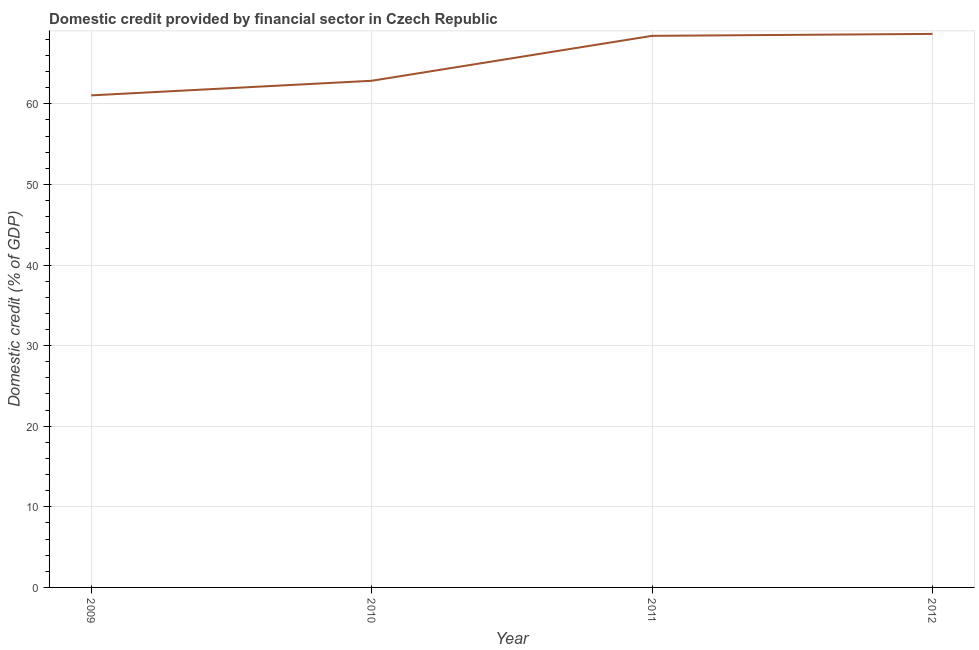What is the domestic credit provided by financial sector in 2010?
Provide a succinct answer. 62.86. Across all years, what is the maximum domestic credit provided by financial sector?
Give a very brief answer. 68.68. Across all years, what is the minimum domestic credit provided by financial sector?
Ensure brevity in your answer.  61.05. In which year was the domestic credit provided by financial sector maximum?
Your response must be concise. 2012. What is the sum of the domestic credit provided by financial sector?
Provide a short and direct response. 261.02. What is the difference between the domestic credit provided by financial sector in 2009 and 2011?
Give a very brief answer. -7.39. What is the average domestic credit provided by financial sector per year?
Ensure brevity in your answer.  65.26. What is the median domestic credit provided by financial sector?
Provide a succinct answer. 65.65. Do a majority of the years between 2011 and 2012 (inclusive) have domestic credit provided by financial sector greater than 50 %?
Provide a short and direct response. Yes. What is the ratio of the domestic credit provided by financial sector in 2009 to that in 2011?
Your response must be concise. 0.89. Is the difference between the domestic credit provided by financial sector in 2009 and 2011 greater than the difference between any two years?
Give a very brief answer. No. What is the difference between the highest and the second highest domestic credit provided by financial sector?
Your answer should be compact. 0.24. Is the sum of the domestic credit provided by financial sector in 2009 and 2010 greater than the maximum domestic credit provided by financial sector across all years?
Offer a terse response. Yes. What is the difference between the highest and the lowest domestic credit provided by financial sector?
Ensure brevity in your answer.  7.63. In how many years, is the domestic credit provided by financial sector greater than the average domestic credit provided by financial sector taken over all years?
Your answer should be very brief. 2. Does the domestic credit provided by financial sector monotonically increase over the years?
Offer a very short reply. Yes. How many lines are there?
Your response must be concise. 1. Are the values on the major ticks of Y-axis written in scientific E-notation?
Your answer should be compact. No. What is the title of the graph?
Provide a short and direct response. Domestic credit provided by financial sector in Czech Republic. What is the label or title of the X-axis?
Provide a short and direct response. Year. What is the label or title of the Y-axis?
Make the answer very short. Domestic credit (% of GDP). What is the Domestic credit (% of GDP) in 2009?
Offer a terse response. 61.05. What is the Domestic credit (% of GDP) in 2010?
Provide a succinct answer. 62.86. What is the Domestic credit (% of GDP) in 2011?
Provide a succinct answer. 68.44. What is the Domestic credit (% of GDP) of 2012?
Make the answer very short. 68.68. What is the difference between the Domestic credit (% of GDP) in 2009 and 2010?
Your response must be concise. -1.81. What is the difference between the Domestic credit (% of GDP) in 2009 and 2011?
Your answer should be very brief. -7.39. What is the difference between the Domestic credit (% of GDP) in 2009 and 2012?
Make the answer very short. -7.63. What is the difference between the Domestic credit (% of GDP) in 2010 and 2011?
Offer a terse response. -5.58. What is the difference between the Domestic credit (% of GDP) in 2010 and 2012?
Provide a short and direct response. -5.82. What is the difference between the Domestic credit (% of GDP) in 2011 and 2012?
Provide a succinct answer. -0.24. What is the ratio of the Domestic credit (% of GDP) in 2009 to that in 2011?
Give a very brief answer. 0.89. What is the ratio of the Domestic credit (% of GDP) in 2009 to that in 2012?
Make the answer very short. 0.89. What is the ratio of the Domestic credit (% of GDP) in 2010 to that in 2011?
Your response must be concise. 0.92. What is the ratio of the Domestic credit (% of GDP) in 2010 to that in 2012?
Offer a very short reply. 0.92. What is the ratio of the Domestic credit (% of GDP) in 2011 to that in 2012?
Provide a short and direct response. 1. 